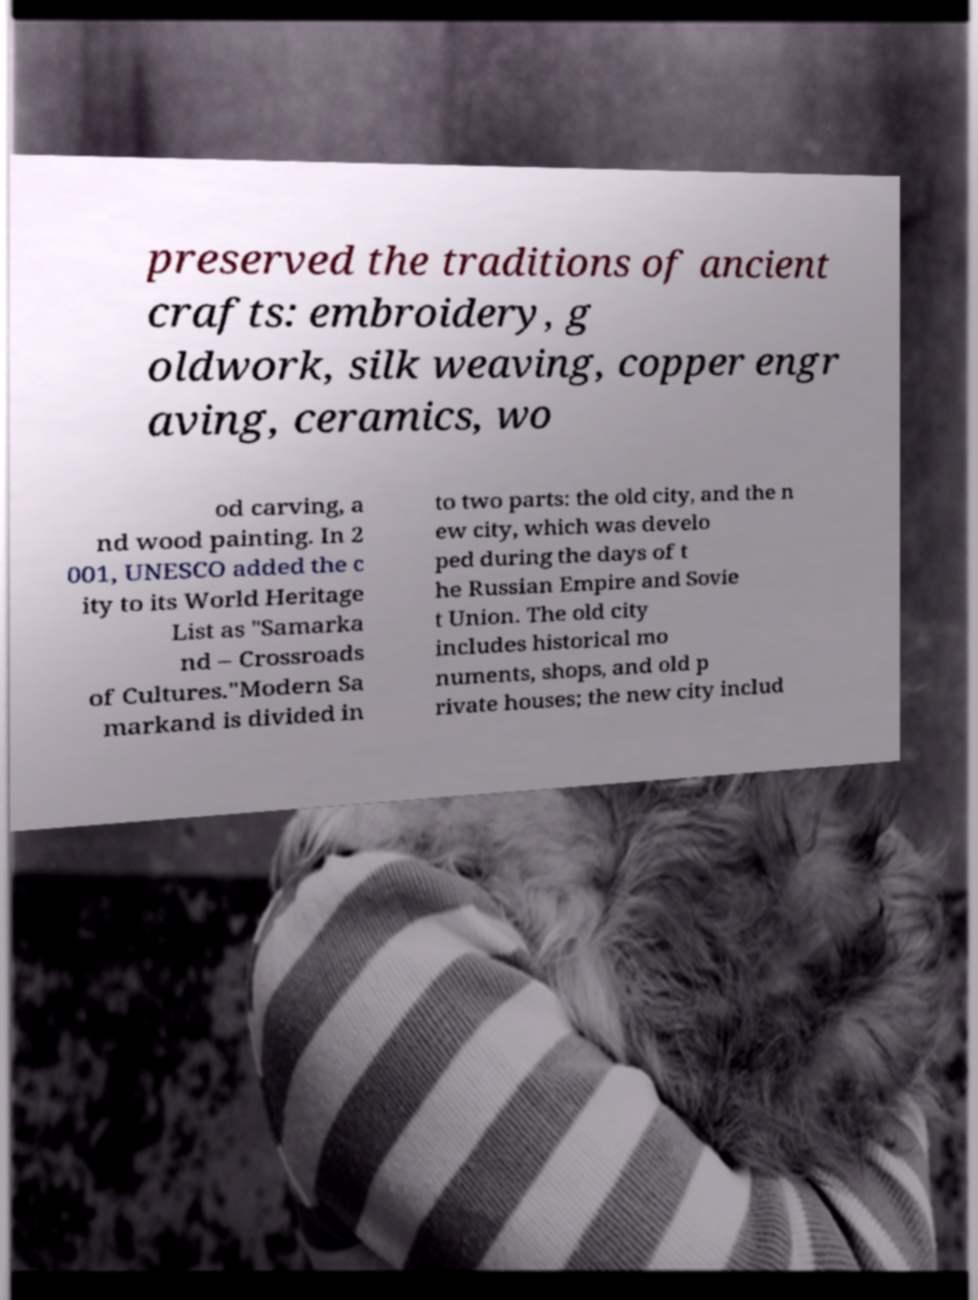Could you extract and type out the text from this image? preserved the traditions of ancient crafts: embroidery, g oldwork, silk weaving, copper engr aving, ceramics, wo od carving, a nd wood painting. In 2 001, UNESCO added the c ity to its World Heritage List as "Samarka nd – Crossroads of Cultures."Modern Sa markand is divided in to two parts: the old city, and the n ew city, which was develo ped during the days of t he Russian Empire and Sovie t Union. The old city includes historical mo numents, shops, and old p rivate houses; the new city includ 